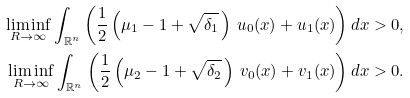<formula> <loc_0><loc_0><loc_500><loc_500>\liminf _ { R \to \infty } \int _ { \mathbb { R } ^ { n } } \left ( \frac { 1 } { 2 } \left ( \mu _ { 1 } - 1 + \sqrt { \delta _ { 1 } } \, \right ) \, u _ { 0 } ( x ) + u _ { 1 } ( x ) \right ) d x > 0 , \\ \liminf _ { R \to \infty } \int _ { \mathbb { R } ^ { n } } \left ( \frac { 1 } { 2 } \left ( \mu _ { 2 } - 1 + \sqrt { \delta _ { 2 } } \, \right ) \, v _ { 0 } ( x ) + v _ { 1 } ( x ) \right ) d x > 0 .</formula> 